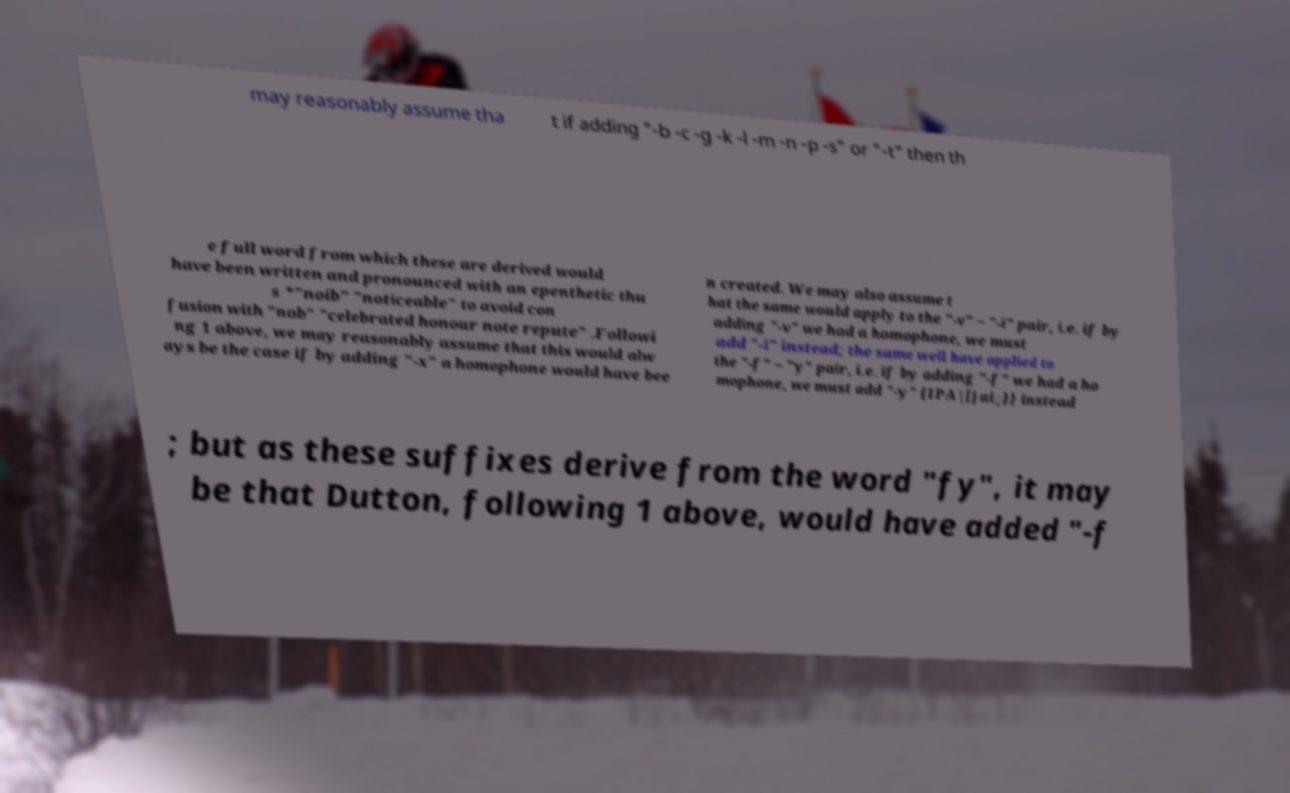Can you read and provide the text displayed in the image?This photo seems to have some interesting text. Can you extract and type it out for me? may reasonably assume tha t if adding "-b -c -g -k -l -m -n -p -s" or "-t" then th e full word from which these are derived would have been written and pronounced with an epenthetic thu s *"noib" "noticeable" to avoid con fusion with "nob" "celebrated honour note repute" .Followi ng 1 above, we may reasonably assume that this would alw ays be the case if by adding "-x" a homophone would have bee n created. We may also assume t hat the same would apply to the "-v" ~ "-i" pair, i.e. if by adding "-v" we had a homophone, we must add "-i" instead; the same well have applied to the "-f" ~ "y" pair, i.e. if by adding "-f" we had a ho mophone, we must add "-y" {IPA|[jai̯}} instead ; but as these suffixes derive from the word "fy", it may be that Dutton, following 1 above, would have added "-f 